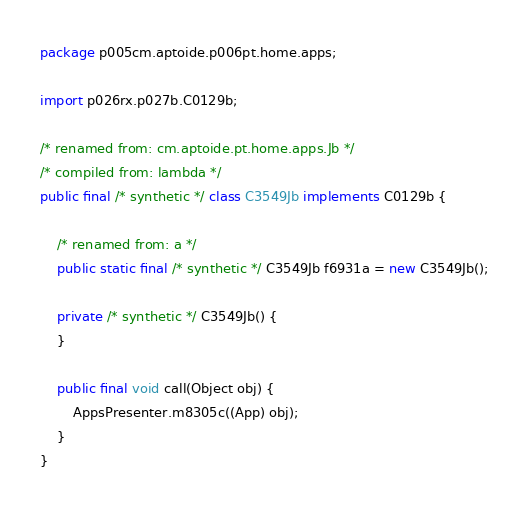<code> <loc_0><loc_0><loc_500><loc_500><_Java_>package p005cm.aptoide.p006pt.home.apps;

import p026rx.p027b.C0129b;

/* renamed from: cm.aptoide.pt.home.apps.Jb */
/* compiled from: lambda */
public final /* synthetic */ class C3549Jb implements C0129b {

    /* renamed from: a */
    public static final /* synthetic */ C3549Jb f6931a = new C3549Jb();

    private /* synthetic */ C3549Jb() {
    }

    public final void call(Object obj) {
        AppsPresenter.m8305c((App) obj);
    }
}
</code> 